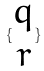Convert formula to latex. <formula><loc_0><loc_0><loc_500><loc_500>\{ \begin{matrix} q \\ r \end{matrix} \}</formula> 